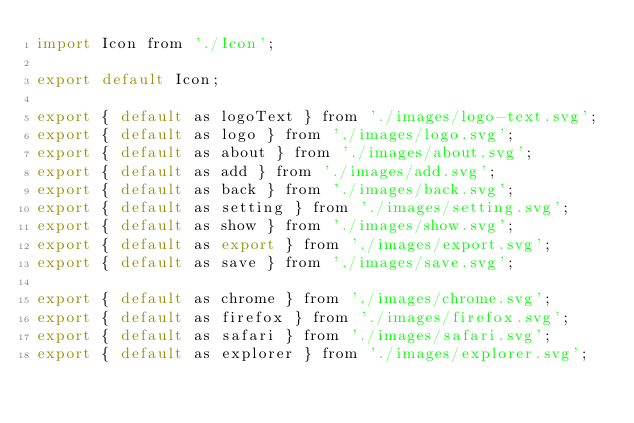Convert code to text. <code><loc_0><loc_0><loc_500><loc_500><_JavaScript_>import Icon from './Icon';

export default Icon;

export { default as logoText } from './images/logo-text.svg';
export { default as logo } from './images/logo.svg';
export { default as about } from './images/about.svg';
export { default as add } from './images/add.svg';
export { default as back } from './images/back.svg';
export { default as setting } from './images/setting.svg';
export { default as show } from './images/show.svg';
export { default as export } from './images/export.svg';
export { default as save } from './images/save.svg';

export { default as chrome } from './images/chrome.svg';
export { default as firefox } from './images/firefox.svg';
export { default as safari } from './images/safari.svg';
export { default as explorer } from './images/explorer.svg';

</code> 